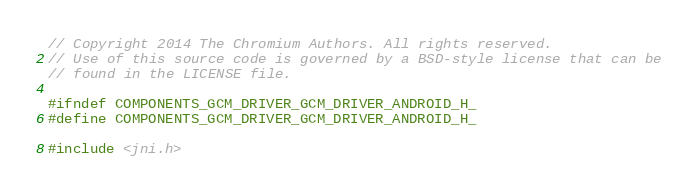Convert code to text. <code><loc_0><loc_0><loc_500><loc_500><_C_>// Copyright 2014 The Chromium Authors. All rights reserved.
// Use of this source code is governed by a BSD-style license that can be
// found in the LICENSE file.

#ifndef COMPONENTS_GCM_DRIVER_GCM_DRIVER_ANDROID_H_
#define COMPONENTS_GCM_DRIVER_GCM_DRIVER_ANDROID_H_

#include <jni.h>
</code> 